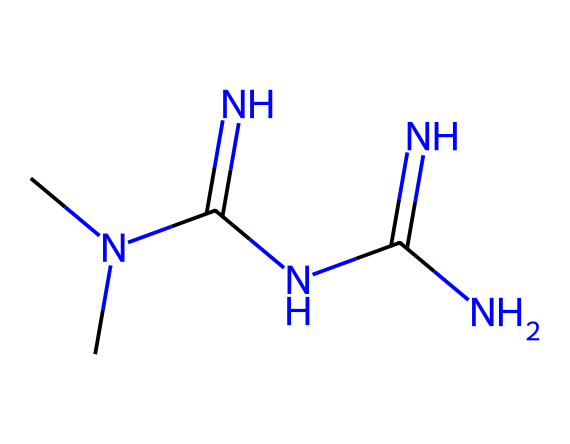What is the molecular formula of metformin? To determine the molecular formula, we identify the number of each type of atom in the SMILES representation. The SMILES indicates there is one carbon (C) and six nitrogen (N) atoms, along with multiple hydrogen (H) atoms that can be inferred based on the valency rules of carbon and nitrogen. Therefore, the molecular formula is C4H11N5.
Answer: C4H11N5 How many nitrogen atoms are in metformin? By examining the SMILES representation, we count the nitrogen symbols (N). There are five instances of nitrogen present in the structure.
Answer: 5 What functional groups are found in metformin? The SMILES notation shows the presence of amine (NH) and guanidine (C(=N)N) functional groups through the nitrogen atoms and bonding arrangements. Thus, these two functional groups are identified in the structure.
Answer: amine, guanidine What is the total number of atoms in metformin? The total atom count is found by adding up all the unique atoms identified in the SMILES. This includes 4 carbon atoms, 11 hydrogen atoms, and 5 nitrogen atoms, resulting in a total of 20 atoms when summed.
Answer: 20 Is metformin a polar or nonpolar compound? The presence of multiple nitrogen and polar bonds generally suggests polar characteristics. The nitrogen atoms, along with the overall molecular composition, also enhance the polarity of metformin. Hence, it can be categorized as polar.
Answer: polar What is the primary therapeutic use of metformin? Metformin is primarily used to manage type 2 diabetes by helping control blood sugar levels. This information is based on its known pharmacological properties and clinical applications.
Answer: type 2 diabetes 